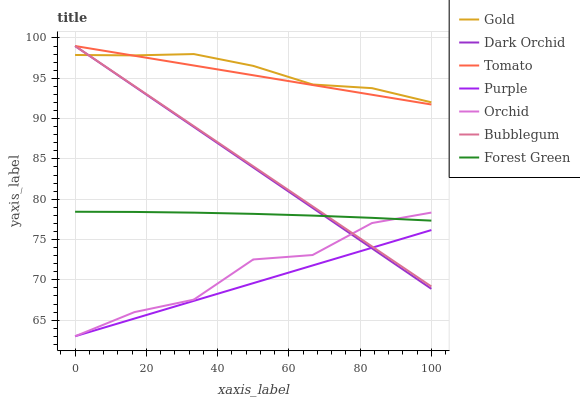Does Purple have the minimum area under the curve?
Answer yes or no. Yes. Does Gold have the maximum area under the curve?
Answer yes or no. Yes. Does Gold have the minimum area under the curve?
Answer yes or no. No. Does Purple have the maximum area under the curve?
Answer yes or no. No. Is Tomato the smoothest?
Answer yes or no. Yes. Is Orchid the roughest?
Answer yes or no. Yes. Is Gold the smoothest?
Answer yes or no. No. Is Gold the roughest?
Answer yes or no. No. Does Purple have the lowest value?
Answer yes or no. Yes. Does Gold have the lowest value?
Answer yes or no. No. Does Dark Orchid have the highest value?
Answer yes or no. Yes. Does Gold have the highest value?
Answer yes or no. No. Is Purple less than Gold?
Answer yes or no. Yes. Is Tomato greater than Orchid?
Answer yes or no. Yes. Does Orchid intersect Dark Orchid?
Answer yes or no. Yes. Is Orchid less than Dark Orchid?
Answer yes or no. No. Is Orchid greater than Dark Orchid?
Answer yes or no. No. Does Purple intersect Gold?
Answer yes or no. No. 